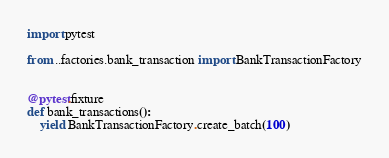<code> <loc_0><loc_0><loc_500><loc_500><_Python_>import pytest

from ..factories.bank_transaction import BankTransactionFactory


@pytest.fixture
def bank_transactions():
    yield BankTransactionFactory.create_batch(100)
</code> 